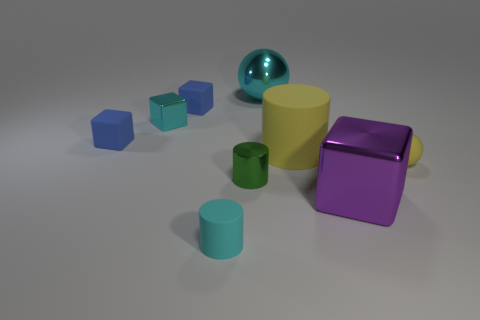The metal thing that is in front of the metal ball and on the right side of the green thing is what color?
Provide a short and direct response. Purple. Does the rubber block left of the cyan shiny block have the same size as the yellow matte cylinder?
Provide a succinct answer. No. There is a rubber cube in front of the cyan metallic cube; is there a cyan rubber cylinder to the right of it?
Make the answer very short. Yes. What material is the small ball?
Provide a succinct answer. Rubber. There is a big cyan object; are there any tiny green shiny things on the right side of it?
Your answer should be very brief. No. There is another object that is the same shape as the tiny yellow thing; what is its size?
Offer a very short reply. Large. Is the number of things that are to the right of the tiny metal cube the same as the number of large spheres right of the rubber ball?
Provide a succinct answer. No. What number of matte blocks are there?
Offer a very short reply. 2. Is the number of large cyan shiny spheres in front of the purple thing greater than the number of tiny yellow spheres?
Your answer should be compact. No. There is a block in front of the yellow sphere; what is it made of?
Make the answer very short. Metal. 